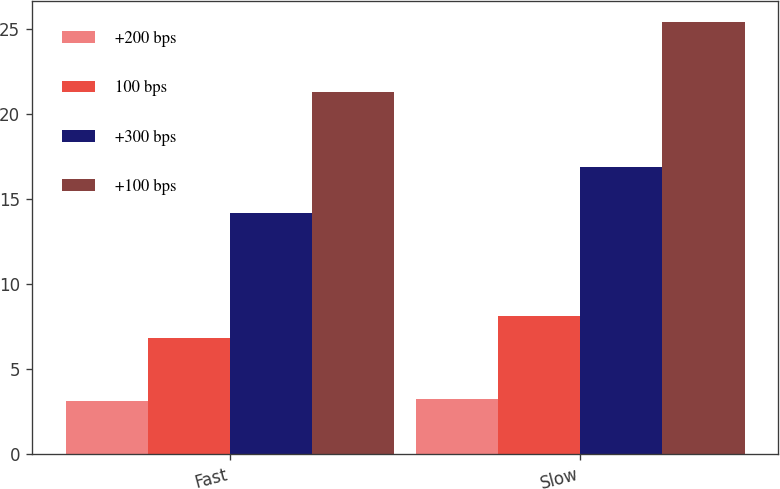Convert chart to OTSL. <chart><loc_0><loc_0><loc_500><loc_500><stacked_bar_chart><ecel><fcel>Fast<fcel>Slow<nl><fcel>+200 bps<fcel>3.1<fcel>3.2<nl><fcel>100 bps<fcel>6.8<fcel>8.1<nl><fcel>+300 bps<fcel>14.2<fcel>16.9<nl><fcel>+100 bps<fcel>21.3<fcel>25.4<nl></chart> 